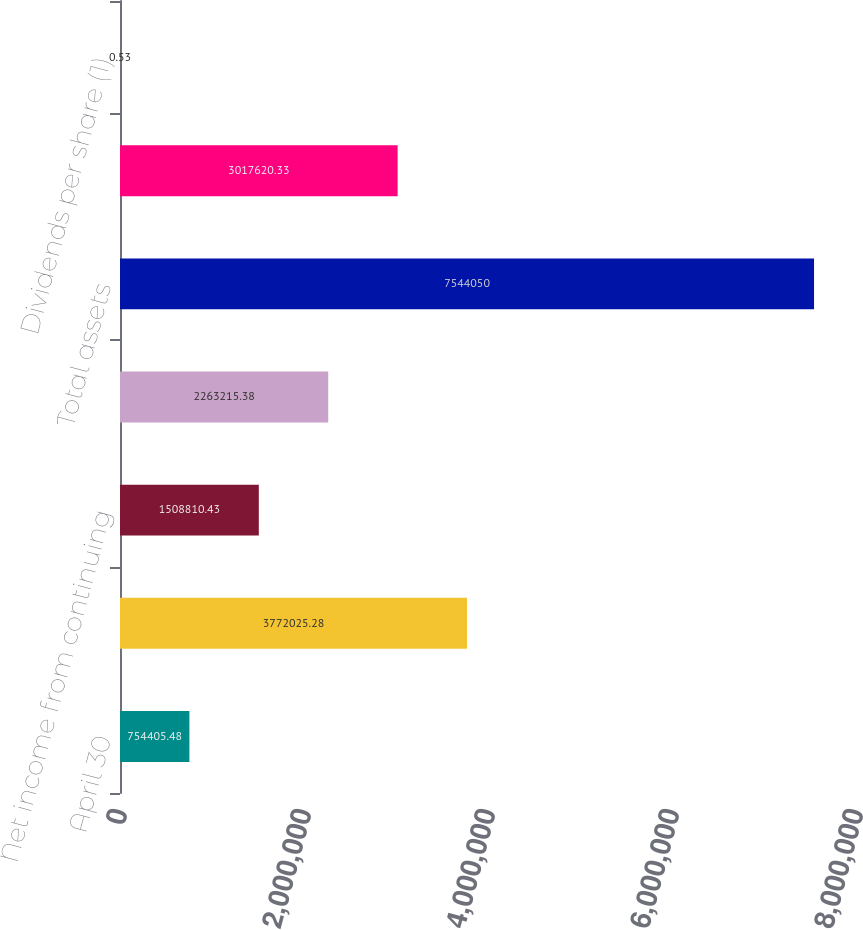Convert chart to OTSL. <chart><loc_0><loc_0><loc_500><loc_500><bar_chart><fcel>April 30<fcel>Revenues<fcel>Net income from continuing<fcel>Net income (loss)<fcel>Total assets<fcel>Long-term debt<fcel>Dividends per share (1)<nl><fcel>754405<fcel>3.77203e+06<fcel>1.50881e+06<fcel>2.26322e+06<fcel>7.54405e+06<fcel>3.01762e+06<fcel>0.53<nl></chart> 